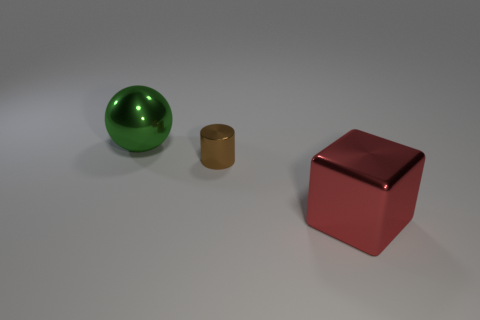Add 3 spheres. How many objects exist? 6 Subtract all cylinders. How many objects are left? 2 Add 3 small cyan spheres. How many small cyan spheres exist? 3 Subtract 0 cyan spheres. How many objects are left? 3 Subtract all big green metal objects. Subtract all large blue matte cubes. How many objects are left? 2 Add 2 balls. How many balls are left? 3 